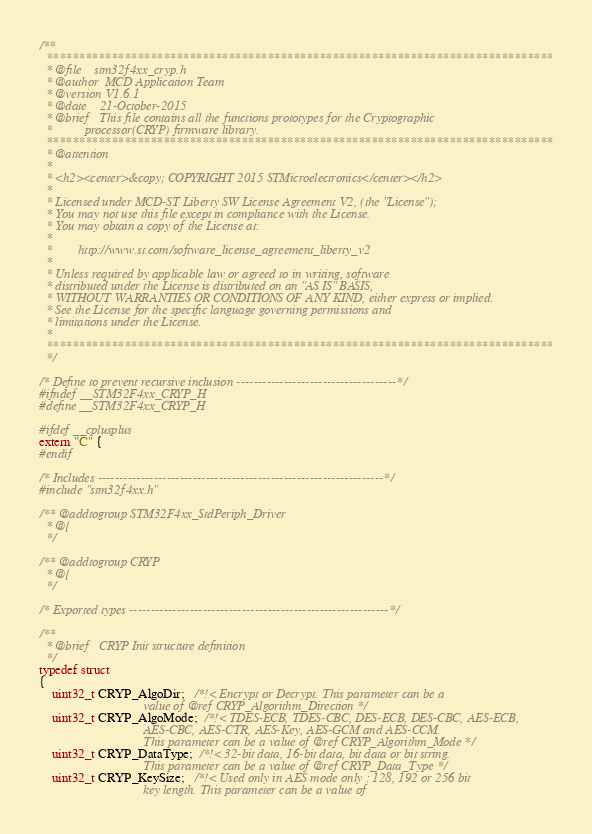Convert code to text. <code><loc_0><loc_0><loc_500><loc_500><_C_>/**
  ******************************************************************************
  * @file    stm32f4xx_cryp.h
  * @author  MCD Application Team
  * @version V1.6.1
  * @date    21-October-2015
  * @brief   This file contains all the functions prototypes for the Cryptographic
  *          processor(CRYP) firmware library.
  ******************************************************************************
  * @attention
  *
  * <h2><center>&copy; COPYRIGHT 2015 STMicroelectronics</center></h2>
  *
  * Licensed under MCD-ST Liberty SW License Agreement V2, (the "License");
  * You may not use this file except in compliance with the License.
  * You may obtain a copy of the License at:
  *
  *        http://www.st.com/software_license_agreement_liberty_v2
  *
  * Unless required by applicable law or agreed to in writing, software
  * distributed under the License is distributed on an "AS IS" BASIS,
  * WITHOUT WARRANTIES OR CONDITIONS OF ANY KIND, either express or implied.
  * See the License for the specific language governing permissions and
  * limitations under the License.
  *
  ******************************************************************************
  */

/* Define to prevent recursive inclusion -------------------------------------*/
#ifndef __STM32F4xx_CRYP_H
#define __STM32F4xx_CRYP_H

#ifdef __cplusplus
extern "C" {
#endif

/* Includes ------------------------------------------------------------------*/
#include "stm32f4xx.h"

/** @addtogroup STM32F4xx_StdPeriph_Driver
  * @{
  */

/** @addtogroup CRYP
  * @{
  */

/* Exported types ------------------------------------------------------------*/

/**
  * @brief   CRYP Init structure definition
  */
typedef struct
{
    uint32_t CRYP_AlgoDir;   /*!< Encrypt or Decrypt. This parameter can be a
                                value of @ref CRYP_Algorithm_Direction */
    uint32_t CRYP_AlgoMode;  /*!< TDES-ECB, TDES-CBC, DES-ECB, DES-CBC, AES-ECB,
                                AES-CBC, AES-CTR, AES-Key, AES-GCM and AES-CCM.
                                This parameter can be a value of @ref CRYP_Algorithm_Mode */
    uint32_t CRYP_DataType;  /*!< 32-bit data, 16-bit data, bit data or bit string.
                                This parameter can be a value of @ref CRYP_Data_Type */
    uint32_t CRYP_KeySize;   /*!< Used only in AES mode only : 128, 192 or 256 bit
                                key length. This parameter can be a value of</code> 